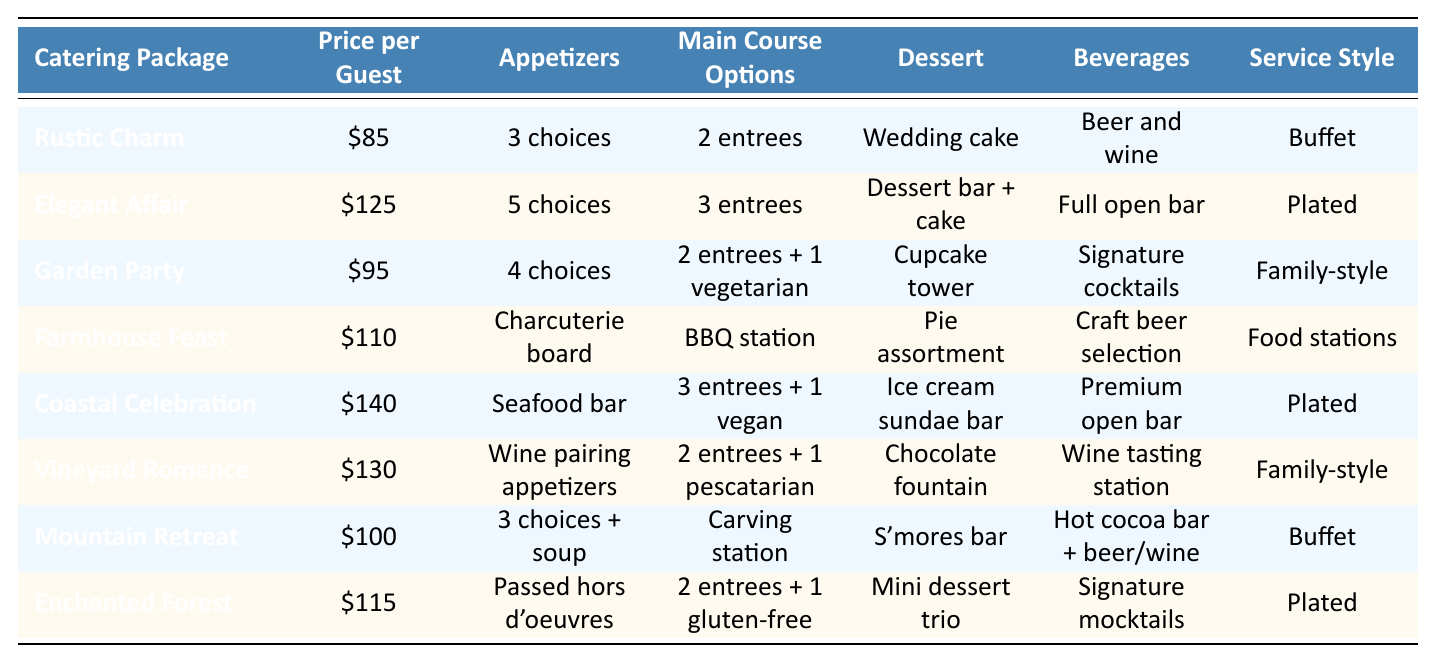What is the most expensive catering package? The table lists the prices for each catering package. Scanning through the "Price per Guest" column, the most expensive package is "Coastal Celebration" at $140.
Answer: Coastal Celebration Which package includes the most appetizer choices? By comparing the "Appetizers" column, "Elegant Affair" offers the most choices with 5 options.
Answer: Elegant Affair How many packages offer a family-style service? Looking in the "Service Style" column, both "Garden Party" and "Vineyard Romance" have family-style service. This means there are 2 packages that offer this.
Answer: 2 What is the price difference between the cheapest and the most expensive catering package? The cheapest package is "Rustic Charm" at $85, and the most expensive is "Coastal Celebration" at $140. The price difference is $140 - $85 = $55.
Answer: $55 Is there a catering package that includes a charcuterie board? In checking the "Appetizers" column, "Farmhouse Feast" is the only package that lists a charcuterie board.
Answer: Yes What is the average price per guest for all catering packages? First, sum the prices: $85 + $125 + $95 + $110 + $140 + $130 + $100 + $115 = $1,000. There are 8 packages, so average price is $1,000 / 8 = $125.
Answer: $125 Which package offers both plated service and a dessert bar? The "Elegant Affair" package includes plated service and also offers a dessert bar with the cake.
Answer: Elegant Affair Which catering package includes a unique dessert option, the chocolate fountain? The dessert "Chocolate fountain" is listed under the "Vineyard Romance" package.
Answer: Vineyard Romance What is the total number of main course options offered by the "Farmhouse Feast"? The "Main Course Options" for "Farmhouse Feast" is a BBQ station. It does not specify a number of options, so we can count it as one option.
Answer: 1 Is there a catering package that includes a premium open bar? The "Coastal Celebration" and "Elegant Affair" packages both feature a premium open bar.
Answer: Yes 